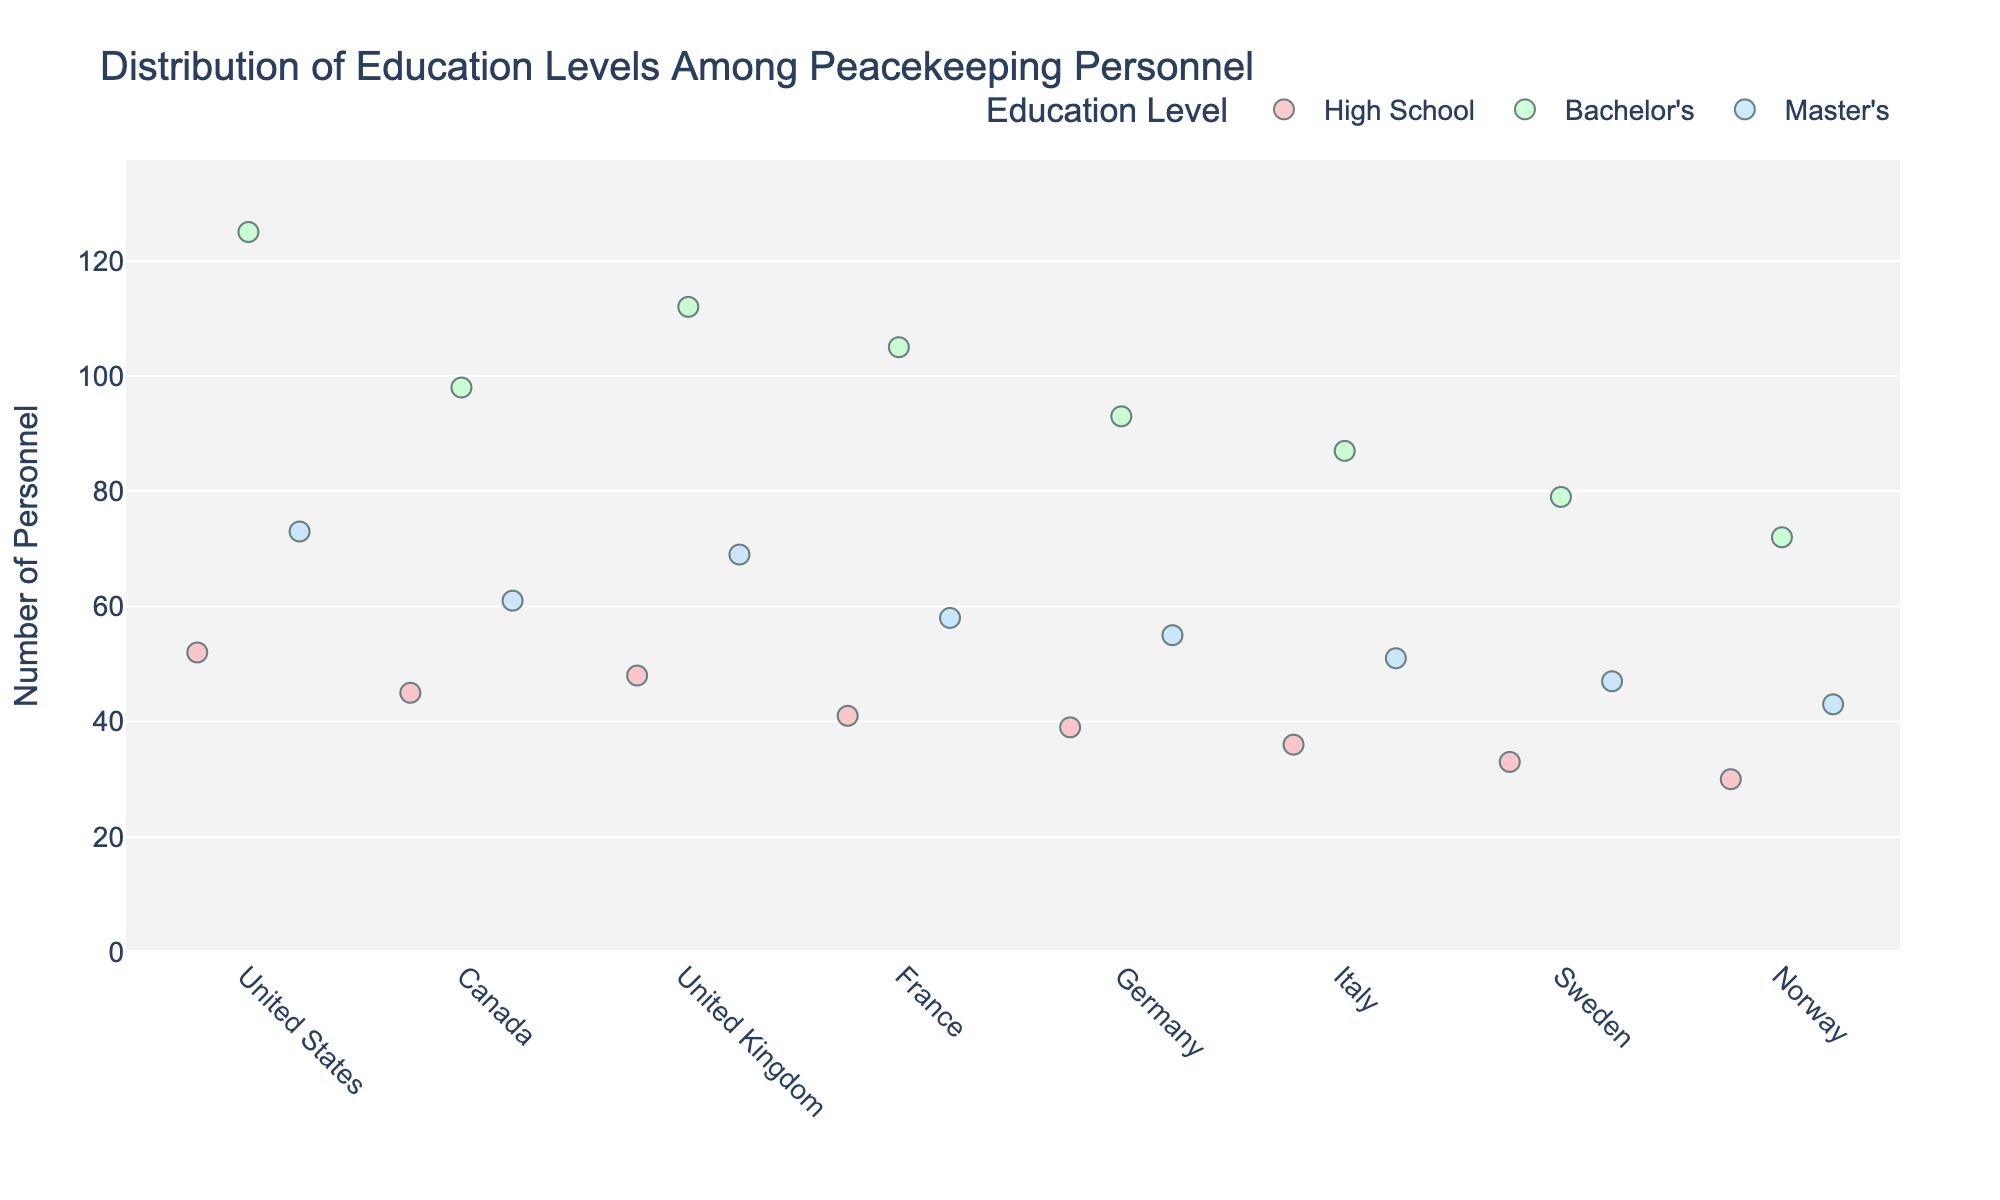What is the title of the plot? The title of the plot is usually located at the top and center of the figure. This plot's title is: "Distribution of Education Levels Among Peacekeeping Personnel".
Answer: Distribution of Education Levels Among Peacekeeping Personnel Which country has the highest number of personnel with a Bachelor's degree? Look for the Bachelor's degree category and identify the tallest strip for each country. The United States has the highest count in this category with 125 personnel.
Answer: United States How many personnel from France have a Master’s degree? Find the Master’s degree strip for France and look at the personnel count. It shows 58 personnel.
Answer: 58 Which education level has the least representation across all countries? Look for the smallest count columns in each country and compare the education levels. High School consistently shows the lowest counts in every country compared to Bachelor's and Master’s.
Answer: High School Which country's peacekeeping personnel have the greatest variation in education levels? To find this, look at the difference between the highest and lowest counts for each country. The United States shows the largest spread between High School (52) and Bachelor's (125), indicating the greatest variation.
Answer: United States What is the total number of peacekeeping personnel from Canada? Sum the personnel counts for all education levels in Canada: 98 (Bachelor's) + 61 (Master's) + 45 (High School) = 204
Answer: 204 Which two countries have nearly similar counts for personnel with a Bachelor’s degree? Look for Bachelor’s degree strips and find similar height strips. The United Kingdom and France both have counts close to each other, with 112 and 105 personnel respectively.
Answer: United Kingdom and France How does the number of personnel with a Master’s degree in Germany compare to those in Sweden? Compare the strip heights for Germany and Sweden in the Master's degree category. Germany has 55 personnel, while Sweden has 47. So, Germany has more personnel with a Master's degree.
Answer: Germany has more Which education level is dominant in the United Kingdom? Find the tallest strip in the United Kingdom category and identify the education level it represents. The Bachelor's degree strip is the tallest with 112 personnel.
Answer: Bachelor's Is there a country where the number of peacekeeping personnel with a High School education exceeds 50? Look at the High School category for each country and check if any strip surpasses 50 personnel. None of the High School strips for any country exceed 50.
Answer: No 